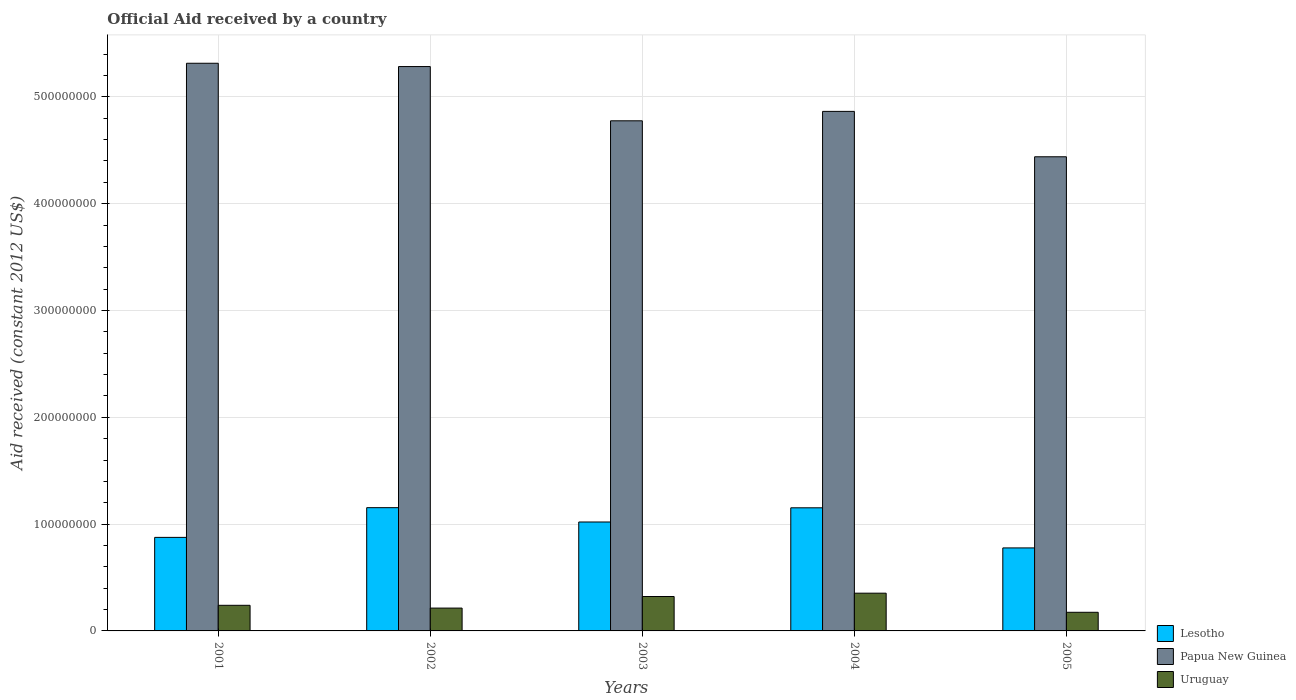How many groups of bars are there?
Offer a terse response. 5. Are the number of bars per tick equal to the number of legend labels?
Offer a terse response. Yes. Are the number of bars on each tick of the X-axis equal?
Provide a succinct answer. Yes. How many bars are there on the 2nd tick from the left?
Offer a very short reply. 3. How many bars are there on the 4th tick from the right?
Keep it short and to the point. 3. What is the label of the 1st group of bars from the left?
Offer a very short reply. 2001. In how many cases, is the number of bars for a given year not equal to the number of legend labels?
Your answer should be very brief. 0. What is the net official aid received in Papua New Guinea in 2003?
Your response must be concise. 4.78e+08. Across all years, what is the maximum net official aid received in Papua New Guinea?
Make the answer very short. 5.31e+08. Across all years, what is the minimum net official aid received in Lesotho?
Provide a short and direct response. 7.77e+07. In which year was the net official aid received in Uruguay maximum?
Make the answer very short. 2004. In which year was the net official aid received in Papua New Guinea minimum?
Ensure brevity in your answer.  2005. What is the total net official aid received in Lesotho in the graph?
Provide a succinct answer. 4.98e+08. What is the difference between the net official aid received in Lesotho in 2002 and that in 2005?
Give a very brief answer. 3.77e+07. What is the difference between the net official aid received in Uruguay in 2003 and the net official aid received in Papua New Guinea in 2005?
Give a very brief answer. -4.12e+08. What is the average net official aid received in Papua New Guinea per year?
Your answer should be compact. 4.94e+08. In the year 2005, what is the difference between the net official aid received in Uruguay and net official aid received in Papua New Guinea?
Provide a succinct answer. -4.26e+08. What is the ratio of the net official aid received in Papua New Guinea in 2004 to that in 2005?
Give a very brief answer. 1.1. Is the net official aid received in Uruguay in 2002 less than that in 2004?
Your answer should be very brief. Yes. What is the difference between the highest and the lowest net official aid received in Uruguay?
Your answer should be very brief. 1.79e+07. In how many years, is the net official aid received in Papua New Guinea greater than the average net official aid received in Papua New Guinea taken over all years?
Keep it short and to the point. 2. What does the 2nd bar from the left in 2005 represents?
Your answer should be compact. Papua New Guinea. What does the 3rd bar from the right in 2004 represents?
Your answer should be very brief. Lesotho. Are all the bars in the graph horizontal?
Your answer should be compact. No. How many years are there in the graph?
Provide a succinct answer. 5. What is the difference between two consecutive major ticks on the Y-axis?
Provide a succinct answer. 1.00e+08. Does the graph contain any zero values?
Your answer should be compact. No. Does the graph contain grids?
Make the answer very short. Yes. Where does the legend appear in the graph?
Make the answer very short. Bottom right. How many legend labels are there?
Keep it short and to the point. 3. How are the legend labels stacked?
Your answer should be compact. Vertical. What is the title of the graph?
Keep it short and to the point. Official Aid received by a country. Does "Costa Rica" appear as one of the legend labels in the graph?
Make the answer very short. No. What is the label or title of the X-axis?
Provide a short and direct response. Years. What is the label or title of the Y-axis?
Provide a short and direct response. Aid received (constant 2012 US$). What is the Aid received (constant 2012 US$) in Lesotho in 2001?
Your response must be concise. 8.76e+07. What is the Aid received (constant 2012 US$) of Papua New Guinea in 2001?
Offer a terse response. 5.31e+08. What is the Aid received (constant 2012 US$) of Uruguay in 2001?
Your answer should be compact. 2.40e+07. What is the Aid received (constant 2012 US$) of Lesotho in 2002?
Provide a succinct answer. 1.15e+08. What is the Aid received (constant 2012 US$) in Papua New Guinea in 2002?
Keep it short and to the point. 5.28e+08. What is the Aid received (constant 2012 US$) of Uruguay in 2002?
Ensure brevity in your answer.  2.14e+07. What is the Aid received (constant 2012 US$) of Lesotho in 2003?
Provide a short and direct response. 1.02e+08. What is the Aid received (constant 2012 US$) in Papua New Guinea in 2003?
Make the answer very short. 4.78e+08. What is the Aid received (constant 2012 US$) in Uruguay in 2003?
Offer a very short reply. 3.22e+07. What is the Aid received (constant 2012 US$) of Lesotho in 2004?
Give a very brief answer. 1.15e+08. What is the Aid received (constant 2012 US$) of Papua New Guinea in 2004?
Give a very brief answer. 4.86e+08. What is the Aid received (constant 2012 US$) in Uruguay in 2004?
Offer a terse response. 3.53e+07. What is the Aid received (constant 2012 US$) in Lesotho in 2005?
Ensure brevity in your answer.  7.77e+07. What is the Aid received (constant 2012 US$) of Papua New Guinea in 2005?
Your answer should be very brief. 4.44e+08. What is the Aid received (constant 2012 US$) of Uruguay in 2005?
Provide a succinct answer. 1.74e+07. Across all years, what is the maximum Aid received (constant 2012 US$) of Lesotho?
Offer a terse response. 1.15e+08. Across all years, what is the maximum Aid received (constant 2012 US$) of Papua New Guinea?
Keep it short and to the point. 5.31e+08. Across all years, what is the maximum Aid received (constant 2012 US$) in Uruguay?
Make the answer very short. 3.53e+07. Across all years, what is the minimum Aid received (constant 2012 US$) of Lesotho?
Your answer should be compact. 7.77e+07. Across all years, what is the minimum Aid received (constant 2012 US$) of Papua New Guinea?
Provide a succinct answer. 4.44e+08. Across all years, what is the minimum Aid received (constant 2012 US$) in Uruguay?
Your response must be concise. 1.74e+07. What is the total Aid received (constant 2012 US$) in Lesotho in the graph?
Give a very brief answer. 4.98e+08. What is the total Aid received (constant 2012 US$) of Papua New Guinea in the graph?
Make the answer very short. 2.47e+09. What is the total Aid received (constant 2012 US$) in Uruguay in the graph?
Give a very brief answer. 1.30e+08. What is the difference between the Aid received (constant 2012 US$) in Lesotho in 2001 and that in 2002?
Keep it short and to the point. -2.78e+07. What is the difference between the Aid received (constant 2012 US$) of Papua New Guinea in 2001 and that in 2002?
Your answer should be compact. 3.09e+06. What is the difference between the Aid received (constant 2012 US$) of Uruguay in 2001 and that in 2002?
Make the answer very short. 2.60e+06. What is the difference between the Aid received (constant 2012 US$) in Lesotho in 2001 and that in 2003?
Ensure brevity in your answer.  -1.44e+07. What is the difference between the Aid received (constant 2012 US$) in Papua New Guinea in 2001 and that in 2003?
Your answer should be very brief. 5.39e+07. What is the difference between the Aid received (constant 2012 US$) of Uruguay in 2001 and that in 2003?
Offer a terse response. -8.24e+06. What is the difference between the Aid received (constant 2012 US$) in Lesotho in 2001 and that in 2004?
Keep it short and to the point. -2.77e+07. What is the difference between the Aid received (constant 2012 US$) in Papua New Guinea in 2001 and that in 2004?
Your answer should be very brief. 4.51e+07. What is the difference between the Aid received (constant 2012 US$) in Uruguay in 2001 and that in 2004?
Offer a terse response. -1.14e+07. What is the difference between the Aid received (constant 2012 US$) in Lesotho in 2001 and that in 2005?
Your response must be concise. 9.86e+06. What is the difference between the Aid received (constant 2012 US$) of Papua New Guinea in 2001 and that in 2005?
Provide a succinct answer. 8.76e+07. What is the difference between the Aid received (constant 2012 US$) of Uruguay in 2001 and that in 2005?
Offer a very short reply. 6.54e+06. What is the difference between the Aid received (constant 2012 US$) in Lesotho in 2002 and that in 2003?
Keep it short and to the point. 1.34e+07. What is the difference between the Aid received (constant 2012 US$) of Papua New Guinea in 2002 and that in 2003?
Offer a terse response. 5.08e+07. What is the difference between the Aid received (constant 2012 US$) of Uruguay in 2002 and that in 2003?
Provide a short and direct response. -1.08e+07. What is the difference between the Aid received (constant 2012 US$) of Papua New Guinea in 2002 and that in 2004?
Make the answer very short. 4.20e+07. What is the difference between the Aid received (constant 2012 US$) of Uruguay in 2002 and that in 2004?
Your answer should be very brief. -1.40e+07. What is the difference between the Aid received (constant 2012 US$) in Lesotho in 2002 and that in 2005?
Offer a terse response. 3.77e+07. What is the difference between the Aid received (constant 2012 US$) of Papua New Guinea in 2002 and that in 2005?
Your answer should be very brief. 8.45e+07. What is the difference between the Aid received (constant 2012 US$) in Uruguay in 2002 and that in 2005?
Provide a succinct answer. 3.94e+06. What is the difference between the Aid received (constant 2012 US$) of Lesotho in 2003 and that in 2004?
Ensure brevity in your answer.  -1.33e+07. What is the difference between the Aid received (constant 2012 US$) of Papua New Guinea in 2003 and that in 2004?
Ensure brevity in your answer.  -8.81e+06. What is the difference between the Aid received (constant 2012 US$) in Uruguay in 2003 and that in 2004?
Keep it short and to the point. -3.11e+06. What is the difference between the Aid received (constant 2012 US$) in Lesotho in 2003 and that in 2005?
Offer a terse response. 2.43e+07. What is the difference between the Aid received (constant 2012 US$) of Papua New Guinea in 2003 and that in 2005?
Give a very brief answer. 3.37e+07. What is the difference between the Aid received (constant 2012 US$) in Uruguay in 2003 and that in 2005?
Provide a short and direct response. 1.48e+07. What is the difference between the Aid received (constant 2012 US$) of Lesotho in 2004 and that in 2005?
Offer a terse response. 3.76e+07. What is the difference between the Aid received (constant 2012 US$) in Papua New Guinea in 2004 and that in 2005?
Your answer should be compact. 4.25e+07. What is the difference between the Aid received (constant 2012 US$) in Uruguay in 2004 and that in 2005?
Keep it short and to the point. 1.79e+07. What is the difference between the Aid received (constant 2012 US$) of Lesotho in 2001 and the Aid received (constant 2012 US$) of Papua New Guinea in 2002?
Your answer should be very brief. -4.41e+08. What is the difference between the Aid received (constant 2012 US$) in Lesotho in 2001 and the Aid received (constant 2012 US$) in Uruguay in 2002?
Ensure brevity in your answer.  6.62e+07. What is the difference between the Aid received (constant 2012 US$) of Papua New Guinea in 2001 and the Aid received (constant 2012 US$) of Uruguay in 2002?
Provide a short and direct response. 5.10e+08. What is the difference between the Aid received (constant 2012 US$) in Lesotho in 2001 and the Aid received (constant 2012 US$) in Papua New Guinea in 2003?
Your response must be concise. -3.90e+08. What is the difference between the Aid received (constant 2012 US$) in Lesotho in 2001 and the Aid received (constant 2012 US$) in Uruguay in 2003?
Provide a short and direct response. 5.54e+07. What is the difference between the Aid received (constant 2012 US$) of Papua New Guinea in 2001 and the Aid received (constant 2012 US$) of Uruguay in 2003?
Offer a terse response. 4.99e+08. What is the difference between the Aid received (constant 2012 US$) of Lesotho in 2001 and the Aid received (constant 2012 US$) of Papua New Guinea in 2004?
Your answer should be very brief. -3.99e+08. What is the difference between the Aid received (constant 2012 US$) of Lesotho in 2001 and the Aid received (constant 2012 US$) of Uruguay in 2004?
Your answer should be very brief. 5.22e+07. What is the difference between the Aid received (constant 2012 US$) of Papua New Guinea in 2001 and the Aid received (constant 2012 US$) of Uruguay in 2004?
Give a very brief answer. 4.96e+08. What is the difference between the Aid received (constant 2012 US$) in Lesotho in 2001 and the Aid received (constant 2012 US$) in Papua New Guinea in 2005?
Your response must be concise. -3.56e+08. What is the difference between the Aid received (constant 2012 US$) of Lesotho in 2001 and the Aid received (constant 2012 US$) of Uruguay in 2005?
Give a very brief answer. 7.01e+07. What is the difference between the Aid received (constant 2012 US$) of Papua New Guinea in 2001 and the Aid received (constant 2012 US$) of Uruguay in 2005?
Provide a short and direct response. 5.14e+08. What is the difference between the Aid received (constant 2012 US$) in Lesotho in 2002 and the Aid received (constant 2012 US$) in Papua New Guinea in 2003?
Provide a succinct answer. -3.62e+08. What is the difference between the Aid received (constant 2012 US$) in Lesotho in 2002 and the Aid received (constant 2012 US$) in Uruguay in 2003?
Make the answer very short. 8.32e+07. What is the difference between the Aid received (constant 2012 US$) of Papua New Guinea in 2002 and the Aid received (constant 2012 US$) of Uruguay in 2003?
Ensure brevity in your answer.  4.96e+08. What is the difference between the Aid received (constant 2012 US$) of Lesotho in 2002 and the Aid received (constant 2012 US$) of Papua New Guinea in 2004?
Ensure brevity in your answer.  -3.71e+08. What is the difference between the Aid received (constant 2012 US$) of Lesotho in 2002 and the Aid received (constant 2012 US$) of Uruguay in 2004?
Your answer should be compact. 8.01e+07. What is the difference between the Aid received (constant 2012 US$) in Papua New Guinea in 2002 and the Aid received (constant 2012 US$) in Uruguay in 2004?
Offer a very short reply. 4.93e+08. What is the difference between the Aid received (constant 2012 US$) in Lesotho in 2002 and the Aid received (constant 2012 US$) in Papua New Guinea in 2005?
Offer a terse response. -3.28e+08. What is the difference between the Aid received (constant 2012 US$) in Lesotho in 2002 and the Aid received (constant 2012 US$) in Uruguay in 2005?
Your answer should be compact. 9.80e+07. What is the difference between the Aid received (constant 2012 US$) in Papua New Guinea in 2002 and the Aid received (constant 2012 US$) in Uruguay in 2005?
Give a very brief answer. 5.11e+08. What is the difference between the Aid received (constant 2012 US$) in Lesotho in 2003 and the Aid received (constant 2012 US$) in Papua New Guinea in 2004?
Keep it short and to the point. -3.84e+08. What is the difference between the Aid received (constant 2012 US$) in Lesotho in 2003 and the Aid received (constant 2012 US$) in Uruguay in 2004?
Ensure brevity in your answer.  6.66e+07. What is the difference between the Aid received (constant 2012 US$) in Papua New Guinea in 2003 and the Aid received (constant 2012 US$) in Uruguay in 2004?
Keep it short and to the point. 4.42e+08. What is the difference between the Aid received (constant 2012 US$) in Lesotho in 2003 and the Aid received (constant 2012 US$) in Papua New Guinea in 2005?
Your answer should be very brief. -3.42e+08. What is the difference between the Aid received (constant 2012 US$) in Lesotho in 2003 and the Aid received (constant 2012 US$) in Uruguay in 2005?
Provide a short and direct response. 8.45e+07. What is the difference between the Aid received (constant 2012 US$) of Papua New Guinea in 2003 and the Aid received (constant 2012 US$) of Uruguay in 2005?
Your answer should be very brief. 4.60e+08. What is the difference between the Aid received (constant 2012 US$) of Lesotho in 2004 and the Aid received (constant 2012 US$) of Papua New Guinea in 2005?
Your response must be concise. -3.29e+08. What is the difference between the Aid received (constant 2012 US$) of Lesotho in 2004 and the Aid received (constant 2012 US$) of Uruguay in 2005?
Your answer should be compact. 9.78e+07. What is the difference between the Aid received (constant 2012 US$) of Papua New Guinea in 2004 and the Aid received (constant 2012 US$) of Uruguay in 2005?
Give a very brief answer. 4.69e+08. What is the average Aid received (constant 2012 US$) of Lesotho per year?
Offer a very short reply. 9.96e+07. What is the average Aid received (constant 2012 US$) of Papua New Guinea per year?
Offer a very short reply. 4.94e+08. What is the average Aid received (constant 2012 US$) in Uruguay per year?
Your answer should be compact. 2.61e+07. In the year 2001, what is the difference between the Aid received (constant 2012 US$) of Lesotho and Aid received (constant 2012 US$) of Papua New Guinea?
Offer a very short reply. -4.44e+08. In the year 2001, what is the difference between the Aid received (constant 2012 US$) of Lesotho and Aid received (constant 2012 US$) of Uruguay?
Your answer should be very brief. 6.36e+07. In the year 2001, what is the difference between the Aid received (constant 2012 US$) of Papua New Guinea and Aid received (constant 2012 US$) of Uruguay?
Your answer should be compact. 5.07e+08. In the year 2002, what is the difference between the Aid received (constant 2012 US$) of Lesotho and Aid received (constant 2012 US$) of Papua New Guinea?
Give a very brief answer. -4.13e+08. In the year 2002, what is the difference between the Aid received (constant 2012 US$) of Lesotho and Aid received (constant 2012 US$) of Uruguay?
Ensure brevity in your answer.  9.40e+07. In the year 2002, what is the difference between the Aid received (constant 2012 US$) in Papua New Guinea and Aid received (constant 2012 US$) in Uruguay?
Your answer should be very brief. 5.07e+08. In the year 2003, what is the difference between the Aid received (constant 2012 US$) in Lesotho and Aid received (constant 2012 US$) in Papua New Guinea?
Make the answer very short. -3.76e+08. In the year 2003, what is the difference between the Aid received (constant 2012 US$) in Lesotho and Aid received (constant 2012 US$) in Uruguay?
Make the answer very short. 6.98e+07. In the year 2003, what is the difference between the Aid received (constant 2012 US$) of Papua New Guinea and Aid received (constant 2012 US$) of Uruguay?
Your answer should be compact. 4.45e+08. In the year 2004, what is the difference between the Aid received (constant 2012 US$) in Lesotho and Aid received (constant 2012 US$) in Papua New Guinea?
Offer a terse response. -3.71e+08. In the year 2004, what is the difference between the Aid received (constant 2012 US$) in Lesotho and Aid received (constant 2012 US$) in Uruguay?
Provide a short and direct response. 7.99e+07. In the year 2004, what is the difference between the Aid received (constant 2012 US$) in Papua New Guinea and Aid received (constant 2012 US$) in Uruguay?
Keep it short and to the point. 4.51e+08. In the year 2005, what is the difference between the Aid received (constant 2012 US$) in Lesotho and Aid received (constant 2012 US$) in Papua New Guinea?
Give a very brief answer. -3.66e+08. In the year 2005, what is the difference between the Aid received (constant 2012 US$) of Lesotho and Aid received (constant 2012 US$) of Uruguay?
Keep it short and to the point. 6.03e+07. In the year 2005, what is the difference between the Aid received (constant 2012 US$) of Papua New Guinea and Aid received (constant 2012 US$) of Uruguay?
Your response must be concise. 4.26e+08. What is the ratio of the Aid received (constant 2012 US$) of Lesotho in 2001 to that in 2002?
Ensure brevity in your answer.  0.76. What is the ratio of the Aid received (constant 2012 US$) of Uruguay in 2001 to that in 2002?
Ensure brevity in your answer.  1.12. What is the ratio of the Aid received (constant 2012 US$) of Lesotho in 2001 to that in 2003?
Make the answer very short. 0.86. What is the ratio of the Aid received (constant 2012 US$) in Papua New Guinea in 2001 to that in 2003?
Provide a succinct answer. 1.11. What is the ratio of the Aid received (constant 2012 US$) in Uruguay in 2001 to that in 2003?
Your answer should be very brief. 0.74. What is the ratio of the Aid received (constant 2012 US$) in Lesotho in 2001 to that in 2004?
Your answer should be compact. 0.76. What is the ratio of the Aid received (constant 2012 US$) of Papua New Guinea in 2001 to that in 2004?
Provide a succinct answer. 1.09. What is the ratio of the Aid received (constant 2012 US$) in Uruguay in 2001 to that in 2004?
Give a very brief answer. 0.68. What is the ratio of the Aid received (constant 2012 US$) of Lesotho in 2001 to that in 2005?
Your response must be concise. 1.13. What is the ratio of the Aid received (constant 2012 US$) in Papua New Guinea in 2001 to that in 2005?
Keep it short and to the point. 1.2. What is the ratio of the Aid received (constant 2012 US$) in Uruguay in 2001 to that in 2005?
Your answer should be compact. 1.38. What is the ratio of the Aid received (constant 2012 US$) in Lesotho in 2002 to that in 2003?
Provide a succinct answer. 1.13. What is the ratio of the Aid received (constant 2012 US$) of Papua New Guinea in 2002 to that in 2003?
Offer a terse response. 1.11. What is the ratio of the Aid received (constant 2012 US$) in Uruguay in 2002 to that in 2003?
Your response must be concise. 0.66. What is the ratio of the Aid received (constant 2012 US$) of Lesotho in 2002 to that in 2004?
Your answer should be compact. 1. What is the ratio of the Aid received (constant 2012 US$) of Papua New Guinea in 2002 to that in 2004?
Give a very brief answer. 1.09. What is the ratio of the Aid received (constant 2012 US$) of Uruguay in 2002 to that in 2004?
Offer a very short reply. 0.61. What is the ratio of the Aid received (constant 2012 US$) in Lesotho in 2002 to that in 2005?
Provide a short and direct response. 1.48. What is the ratio of the Aid received (constant 2012 US$) of Papua New Guinea in 2002 to that in 2005?
Make the answer very short. 1.19. What is the ratio of the Aid received (constant 2012 US$) in Uruguay in 2002 to that in 2005?
Your answer should be compact. 1.23. What is the ratio of the Aid received (constant 2012 US$) in Lesotho in 2003 to that in 2004?
Offer a terse response. 0.88. What is the ratio of the Aid received (constant 2012 US$) of Papua New Guinea in 2003 to that in 2004?
Make the answer very short. 0.98. What is the ratio of the Aid received (constant 2012 US$) in Uruguay in 2003 to that in 2004?
Your answer should be compact. 0.91. What is the ratio of the Aid received (constant 2012 US$) in Lesotho in 2003 to that in 2005?
Offer a terse response. 1.31. What is the ratio of the Aid received (constant 2012 US$) of Papua New Guinea in 2003 to that in 2005?
Provide a short and direct response. 1.08. What is the ratio of the Aid received (constant 2012 US$) of Uruguay in 2003 to that in 2005?
Provide a short and direct response. 1.85. What is the ratio of the Aid received (constant 2012 US$) in Lesotho in 2004 to that in 2005?
Provide a succinct answer. 1.48. What is the ratio of the Aid received (constant 2012 US$) of Papua New Guinea in 2004 to that in 2005?
Your response must be concise. 1.1. What is the ratio of the Aid received (constant 2012 US$) of Uruguay in 2004 to that in 2005?
Your answer should be compact. 2.03. What is the difference between the highest and the second highest Aid received (constant 2012 US$) in Lesotho?
Your answer should be very brief. 1.30e+05. What is the difference between the highest and the second highest Aid received (constant 2012 US$) of Papua New Guinea?
Give a very brief answer. 3.09e+06. What is the difference between the highest and the second highest Aid received (constant 2012 US$) in Uruguay?
Offer a very short reply. 3.11e+06. What is the difference between the highest and the lowest Aid received (constant 2012 US$) in Lesotho?
Ensure brevity in your answer.  3.77e+07. What is the difference between the highest and the lowest Aid received (constant 2012 US$) in Papua New Guinea?
Provide a succinct answer. 8.76e+07. What is the difference between the highest and the lowest Aid received (constant 2012 US$) of Uruguay?
Ensure brevity in your answer.  1.79e+07. 